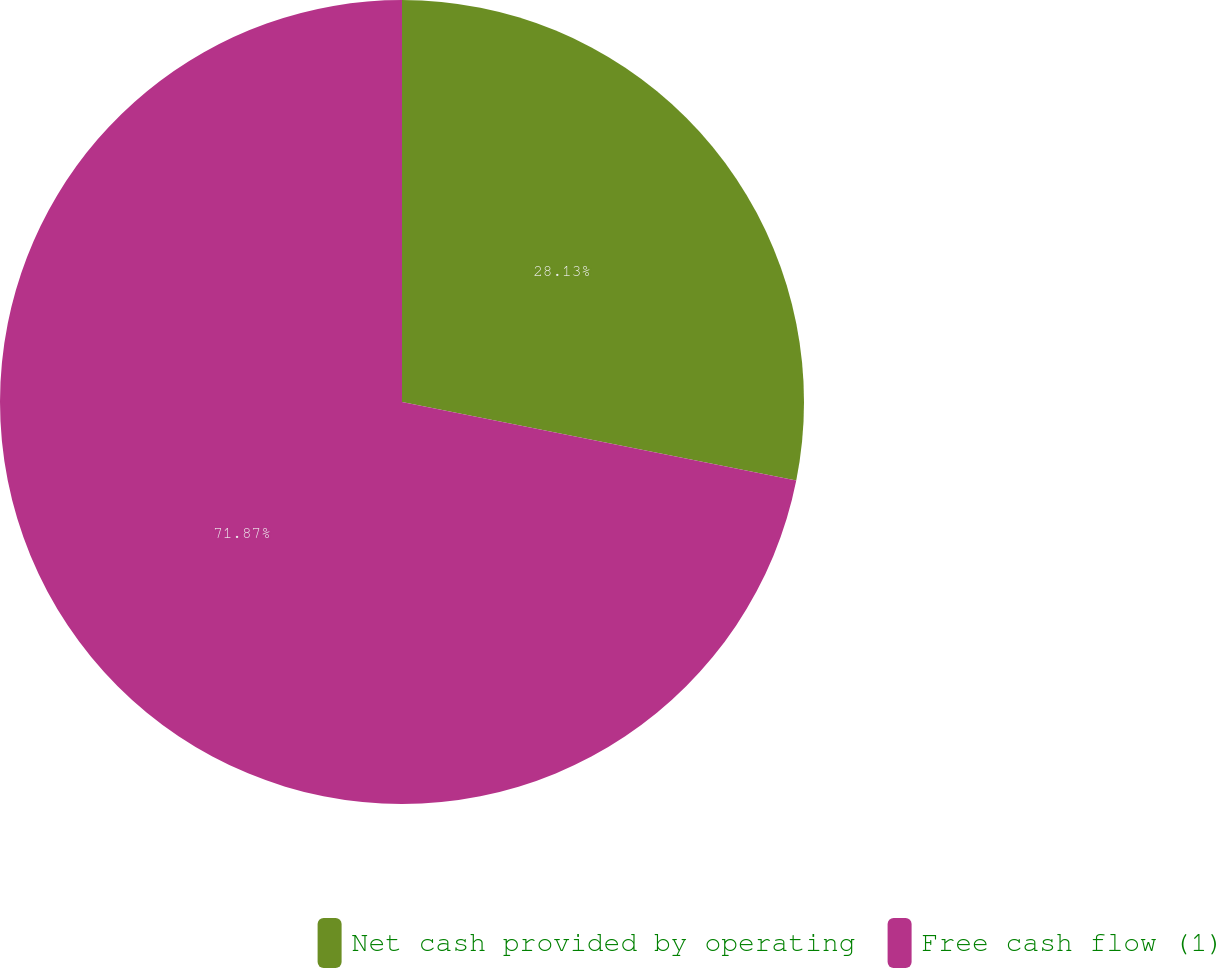Convert chart. <chart><loc_0><loc_0><loc_500><loc_500><pie_chart><fcel>Net cash provided by operating<fcel>Free cash flow (1)<nl><fcel>28.13%<fcel>71.87%<nl></chart> 